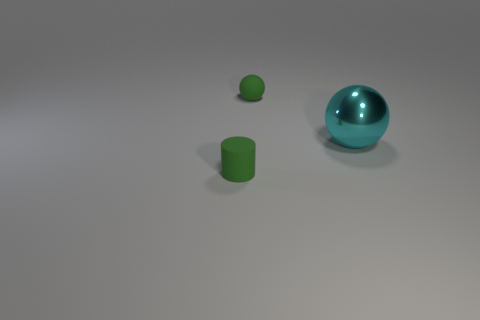Add 2 green matte cylinders. How many objects exist? 5 Subtract 1 cylinders. How many cylinders are left? 0 Subtract all blue cylinders. Subtract all green cubes. How many cylinders are left? 1 Subtract all brown blocks. How many gray spheres are left? 0 Subtract all small rubber balls. Subtract all green matte objects. How many objects are left? 0 Add 2 cyan metallic objects. How many cyan metallic objects are left? 3 Add 1 large yellow metal cylinders. How many large yellow metal cylinders exist? 1 Subtract all cyan spheres. How many spheres are left? 1 Subtract 0 yellow spheres. How many objects are left? 3 Subtract all cylinders. How many objects are left? 2 